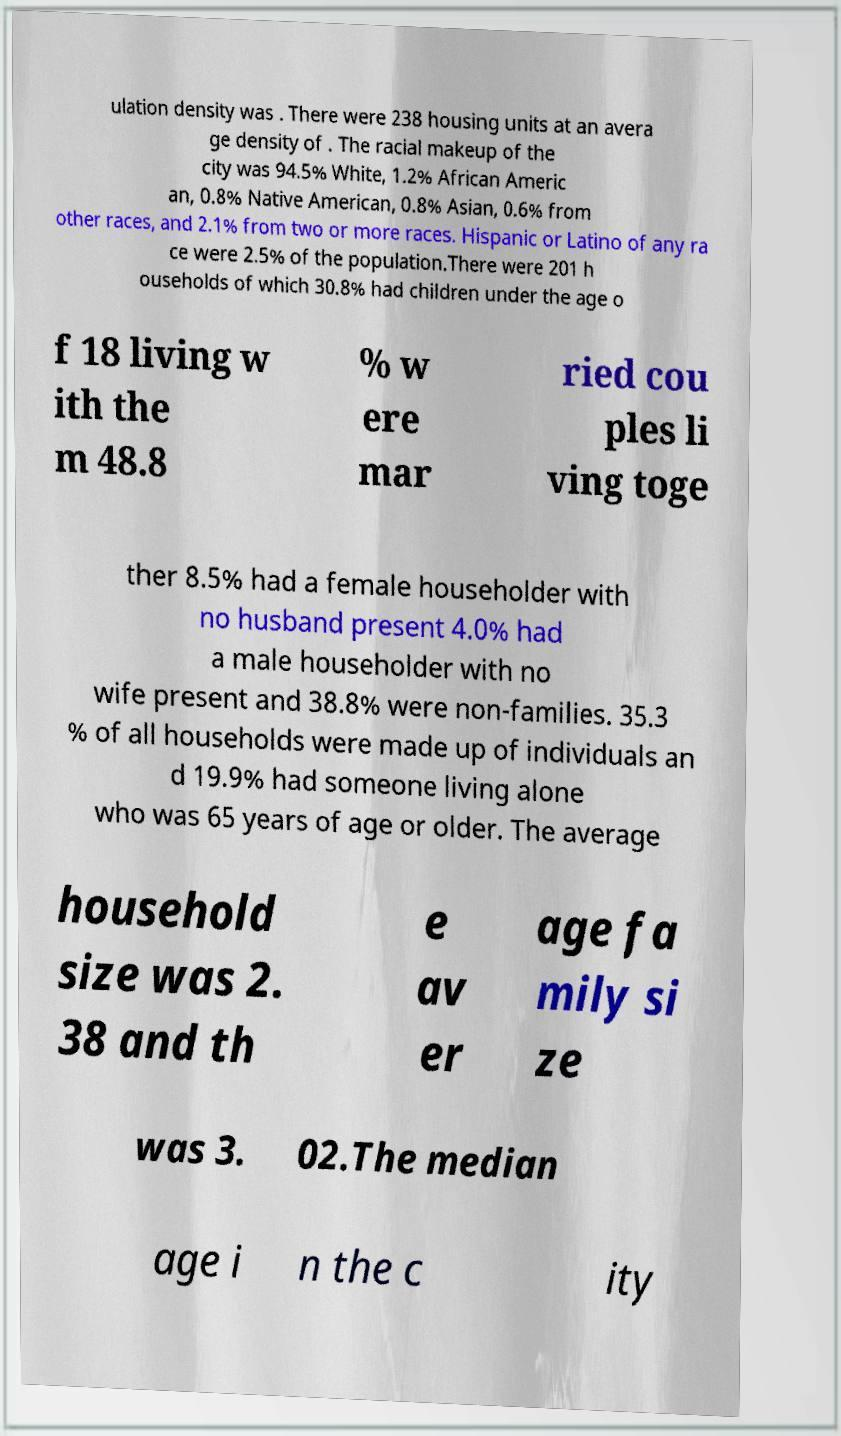Could you extract and type out the text from this image? ulation density was . There were 238 housing units at an avera ge density of . The racial makeup of the city was 94.5% White, 1.2% African Americ an, 0.8% Native American, 0.8% Asian, 0.6% from other races, and 2.1% from two or more races. Hispanic or Latino of any ra ce were 2.5% of the population.There were 201 h ouseholds of which 30.8% had children under the age o f 18 living w ith the m 48.8 % w ere mar ried cou ples li ving toge ther 8.5% had a female householder with no husband present 4.0% had a male householder with no wife present and 38.8% were non-families. 35.3 % of all households were made up of individuals an d 19.9% had someone living alone who was 65 years of age or older. The average household size was 2. 38 and th e av er age fa mily si ze was 3. 02.The median age i n the c ity 